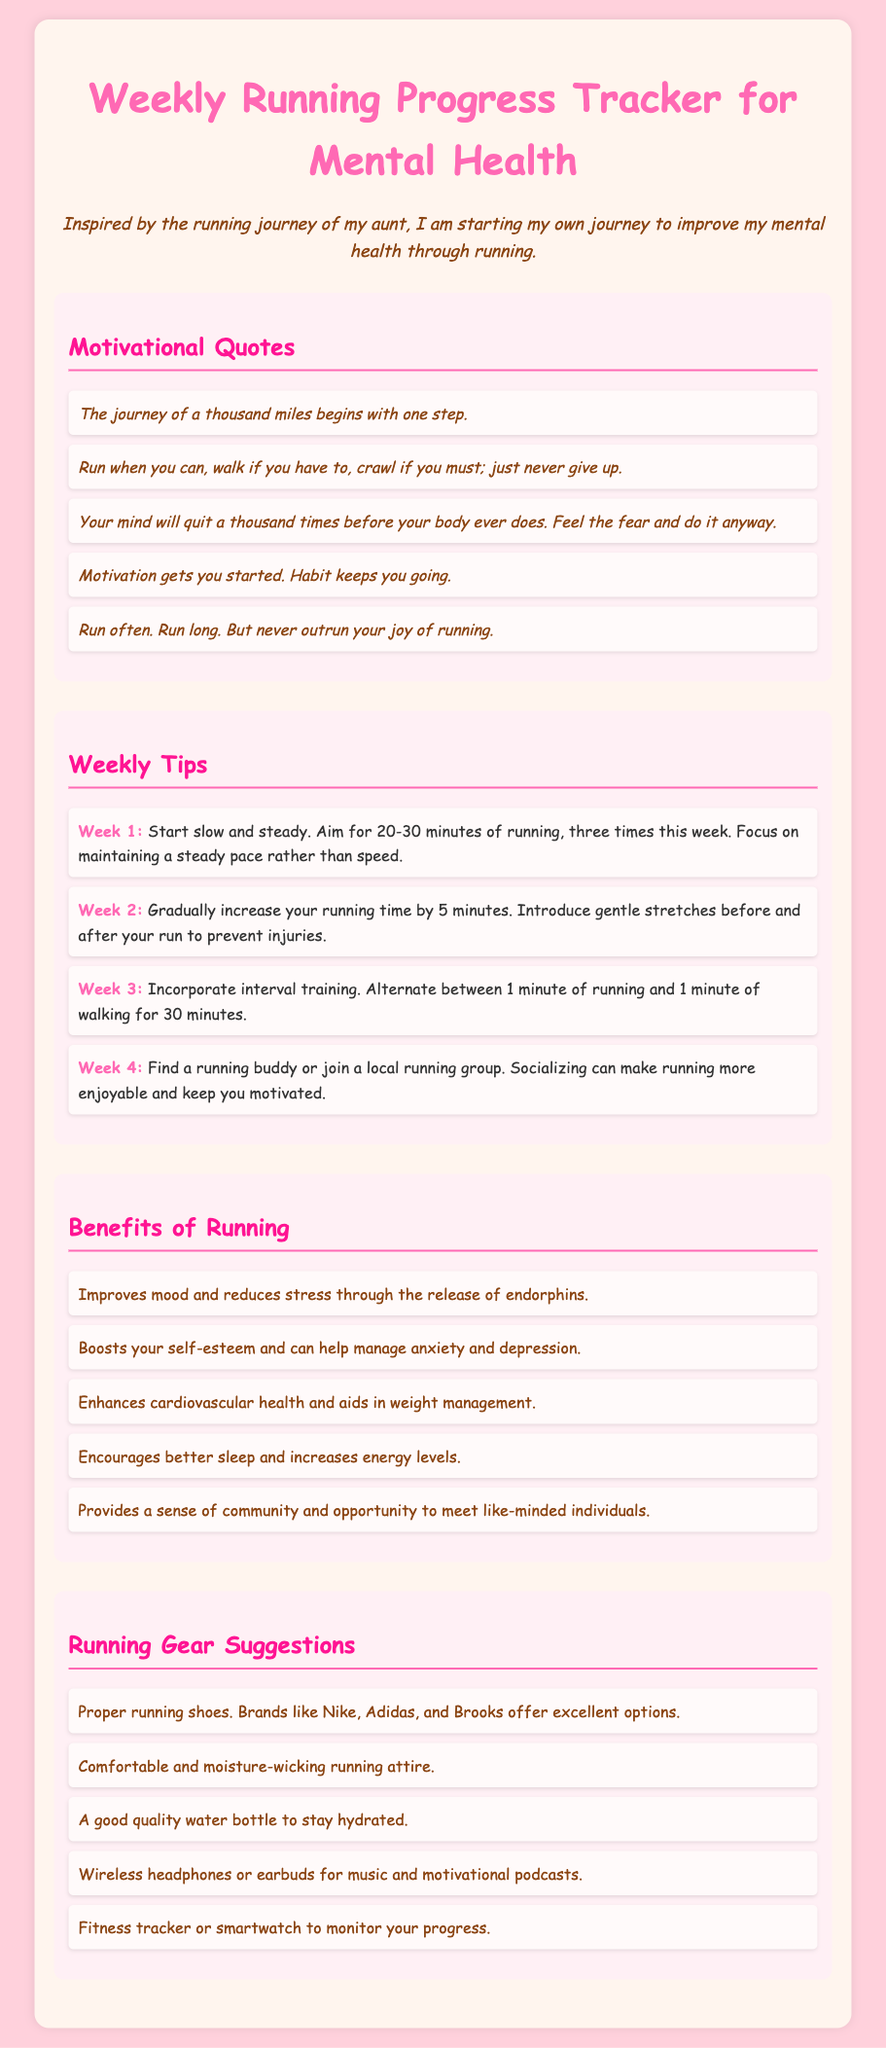What is the title of the document? The title is found in the header section of the document, which describes its purpose.
Answer: Weekly Running Progress Tracker for Mental Health What is the color of the section titles? The color of the section titles is specified in the document's style.
Answer: #FF1493 How many weeks of tips are provided? The document lists tips for a total of four weeks.
Answer: 4 What is one benefit of running mentioned in the document? The benefits of running are listed in a specific section of the document.
Answer: Improves mood and reduces stress through the release of endorphins What is the focus of Week 2's tip? The focus of Week 2's tip can be found in the list of weekly tips.
Answer: Gradually increase your running time by 5 minutes Which brands are suggested for proper running shoes? The document specifically mentions a few brand options for running shoes in the gear section.
Answer: Nike, Adidas, and Brooks What motivational quote mentions the concept of persistence? A specific quote in the motivational section emphasizes the idea of not giving up.
Answer: Run when you can, walk if you have to, crawl if you must; just never give up What is recommended to stay hydrated while running? The document suggests a specific item for hydration in the running gear suggestions.
Answer: A good quality water bottle 